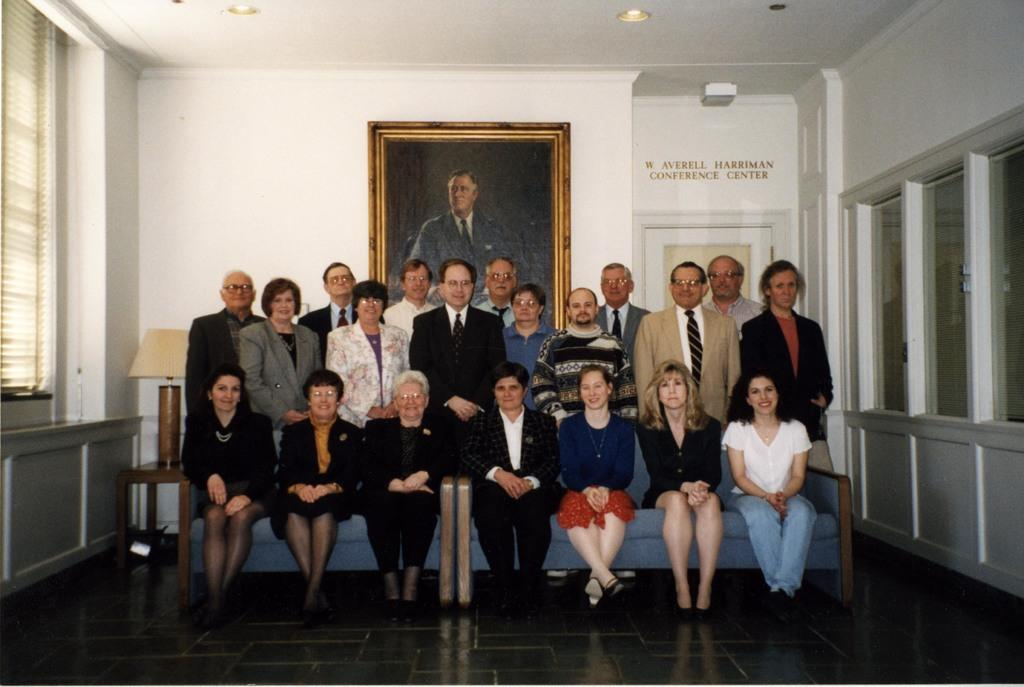What is the color of the wall in the image? The wall in the image is white. What can be seen on the wall in the image? There is a window and a photo frame on the wall in the image. What are the people in the image doing? Some people are sitting on a sofa, and some are standing in the image. What type of question is being asked in the image? There is no question being asked in the image; it is a still scene with people sitting and standing. 